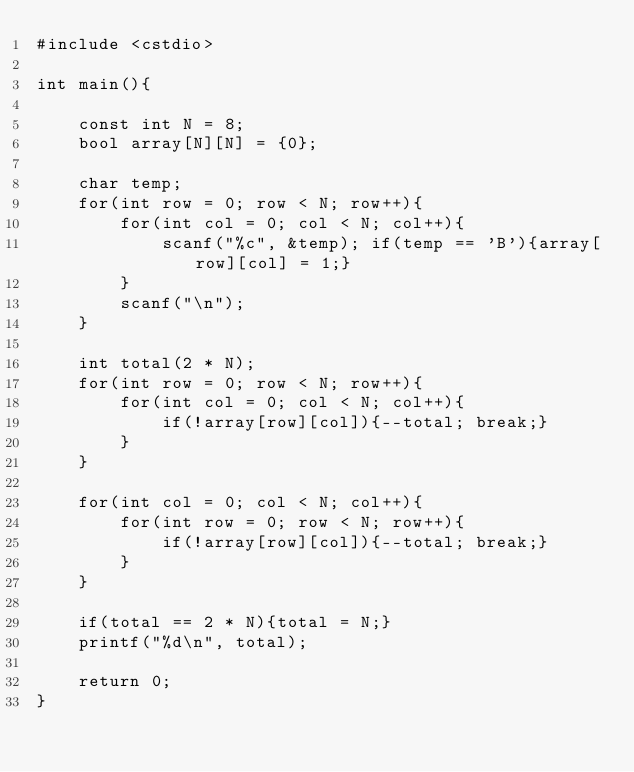<code> <loc_0><loc_0><loc_500><loc_500><_C++_>#include <cstdio>

int main(){

    const int N = 8;
    bool array[N][N] = {0};

    char temp;
    for(int row = 0; row < N; row++){
        for(int col = 0; col < N; col++){
            scanf("%c", &temp); if(temp == 'B'){array[row][col] = 1;}
        }
        scanf("\n");
    }

    int total(2 * N);
    for(int row = 0; row < N; row++){
        for(int col = 0; col < N; col++){
            if(!array[row][col]){--total; break;}
        }
    }

    for(int col = 0; col < N; col++){
        for(int row = 0; row < N; row++){
            if(!array[row][col]){--total; break;}
        }
    }

    if(total == 2 * N){total = N;}
    printf("%d\n", total);

    return 0;
}
</code> 